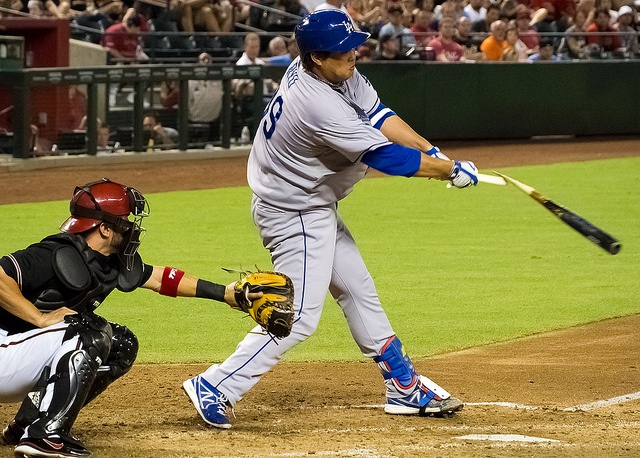Describe the objects in this image and their specific colors. I can see people in gray, lightgray, darkgray, and black tones, people in gray, black, lavender, and maroon tones, people in gray, black, and maroon tones, baseball glove in gray, black, orange, olive, and lightgray tones, and people in gray, maroon, black, and brown tones in this image. 